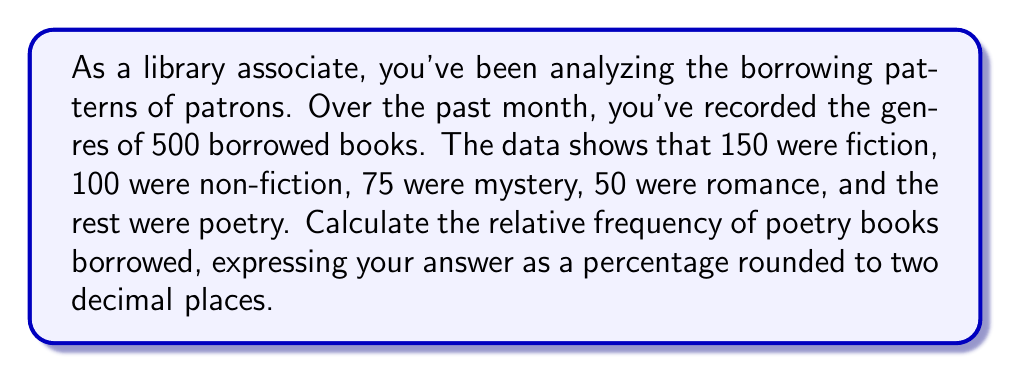Can you answer this question? Let's approach this step-by-step:

1) First, we need to find the number of poetry books borrowed. We can do this by subtracting the sum of all other genres from the total:

   Total books = 500
   Sum of other genres = 150 + 100 + 75 + 50 = 375
   Poetry books = 500 - 375 = 125

2) Now, to calculate the relative frequency, we use the formula:

   $$ \text{Relative Frequency} = \frac{\text{Frequency of Category}}{\text{Total Frequency}} $$

3) Plugging in our numbers:

   $$ \text{Relative Frequency of Poetry} = \frac{125}{500} = 0.25 $$

4) To express this as a percentage, we multiply by 100:

   $$ 0.25 \times 100 = 25\% $$

5) The question asks for the result rounded to two decimal places, but 25% already fits this criterion.
Answer: 25.00% 